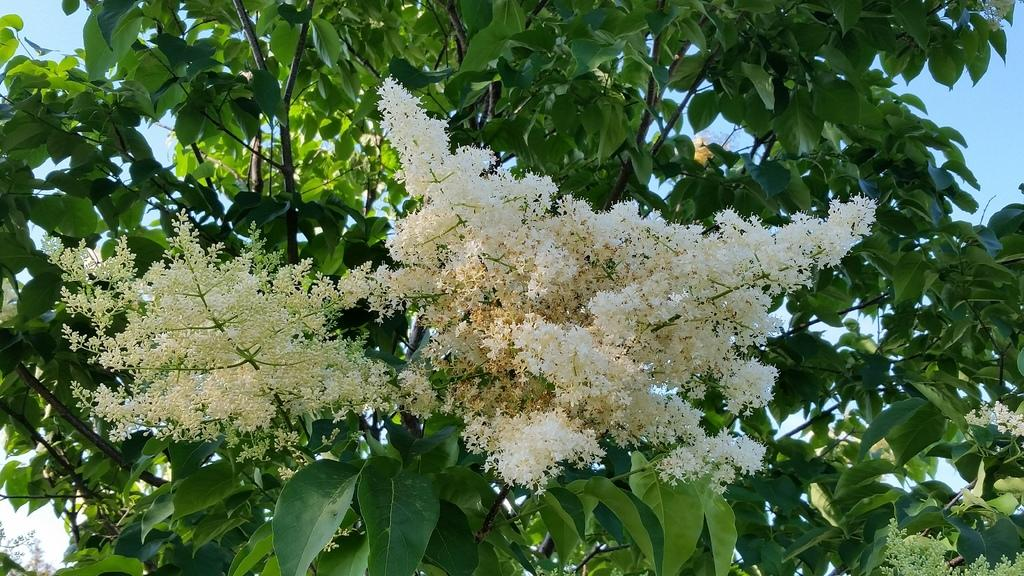What type of plants can be seen in the foreground of the image? There are flowers in the foreground of the image. What type of vegetation is visible in the background of the image? There are trees in the background of the image. What else can be seen in the background of the image? The sky is visible in the background of the image. What is the rate at which the bun is growing in the image? There is no bun present in the image, so it is not possible to determine its growth rate. 